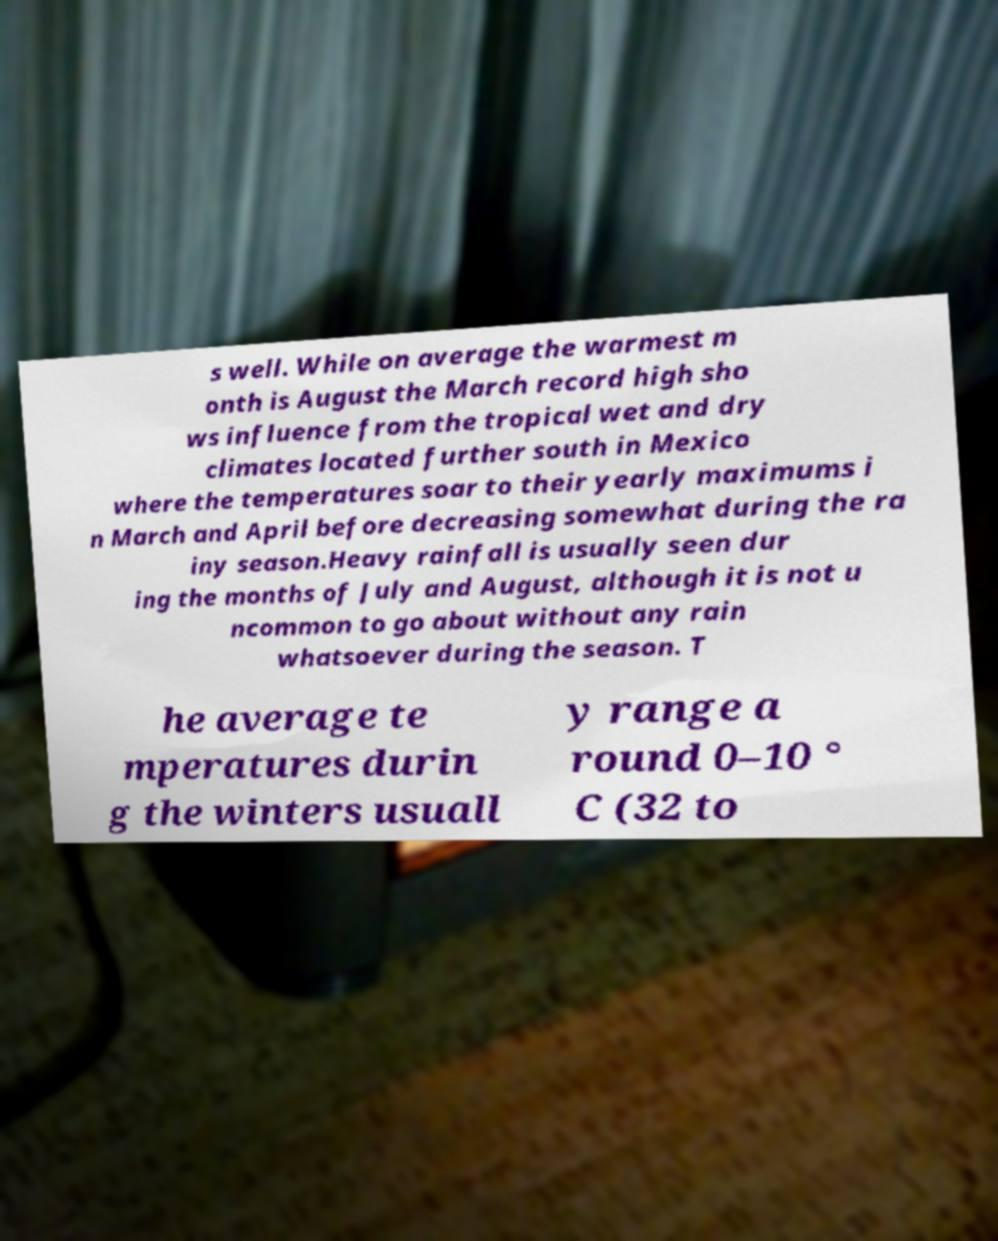Please identify and transcribe the text found in this image. s well. While on average the warmest m onth is August the March record high sho ws influence from the tropical wet and dry climates located further south in Mexico where the temperatures soar to their yearly maximums i n March and April before decreasing somewhat during the ra iny season.Heavy rainfall is usually seen dur ing the months of July and August, although it is not u ncommon to go about without any rain whatsoever during the season. T he average te mperatures durin g the winters usuall y range a round 0–10 ° C (32 to 